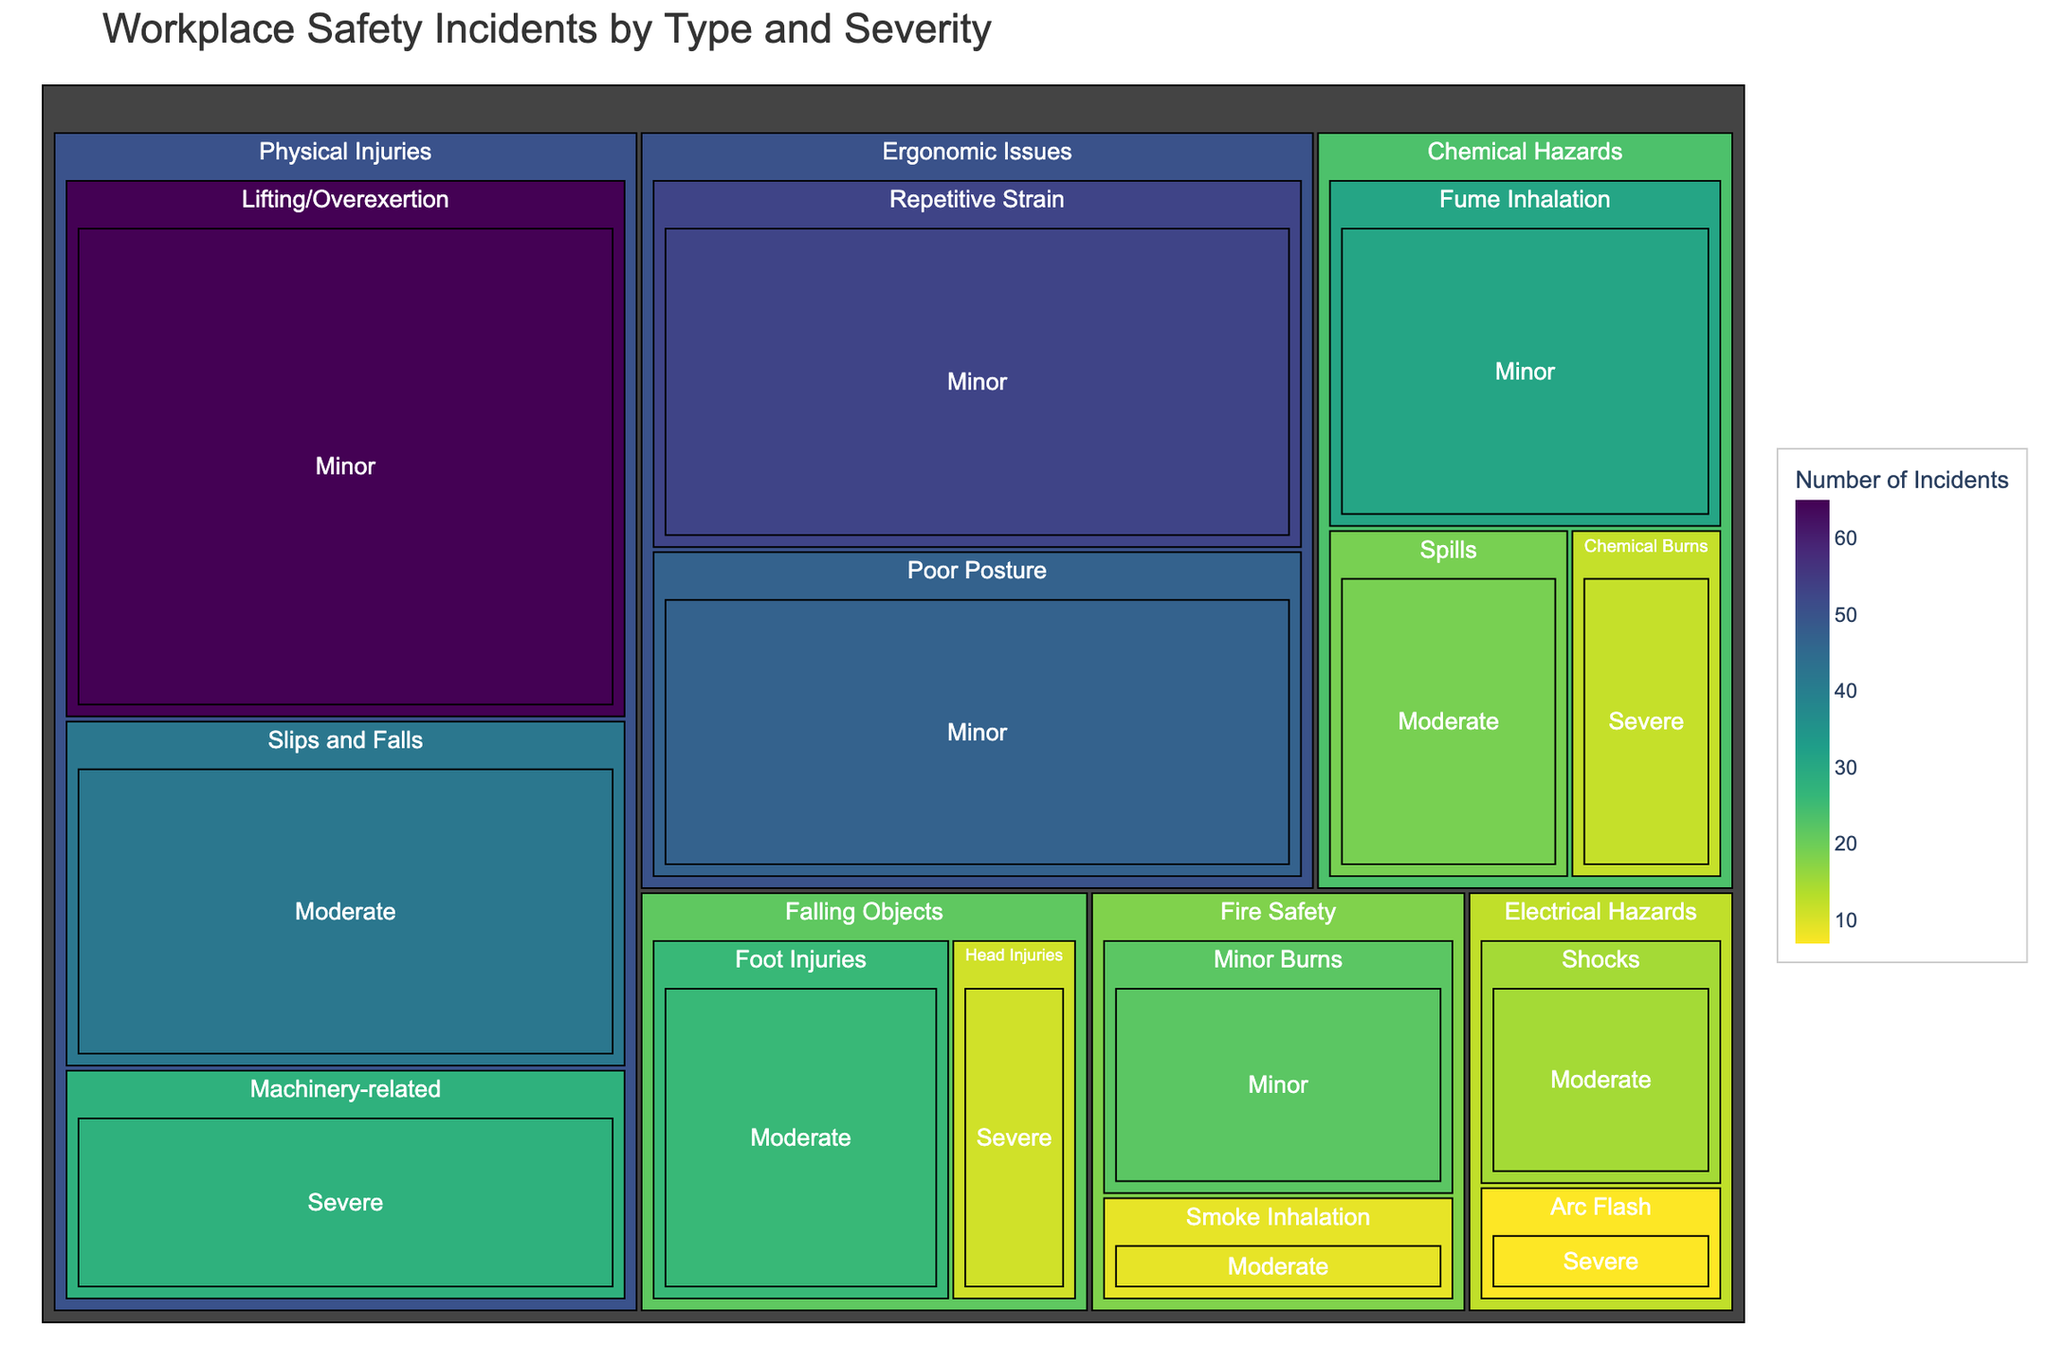What is the title of the treemap? The title of the treemap is displayed prominently at the top and provides an overview of the figure.
Answer: Workplace Safety Incidents by Type and Severity Which category has the highest number of total incidents? To determine the highest category, sum the incidents for each main category (Physical Injuries, Chemical Hazards, Ergonomic Issues, Electrical Hazards, Fire Safety, Falling Objects) and compare the totals. For example, Physical Injuries: 42 + 28 + 65 = 135. Proceed similarly for other categories.
Answer: Physical Injuries How many severe incidents are due to machinery-related accidents? Locate the Machinery-related section under Physical Injuries and find the number specified for severe incidents.
Answer: 28 What is the total number of moderate incidents in the treemap? Sum the incidents for all moderate severity subtotals. For example, Slips and Falls (42), Spills (19), Shocks (15), Smoke Inhalation (9), Head Injuries (11), Foot Injuries (26). Total = 42 + 19 + 15 + 9 + 11 + 26 = 122.
Answer: 122 Which type of incident under Chemical Hazards has the least number of incidents? Examine the subdivisions under Chemical Hazards for the lowest value. Compare Spills (19), Fume Inhalation (31), Chemical Burns (12).
Answer: Chemical Burns How does the number of minor ergonomic issues compare with minor fire safety incidents? Find and compare the values for Repetitive Strain (53) and Poor Posture (47) under Ergonomic Issues against Minor Burns (22) under Fire Safety. Total Ergonomic Issues (53 + 47 = 100) vs. Fire Safety (22).
Answer: Ergonomic Issues have more What is the proportion of severe incidents within the Physical Injuries category? Calculate the proportion of severe incidents by dividing Machinery-related (28) by the total incidents in Physical Injuries (135). Proportion = 28 / 135 ≈ 0.207.
Answer: 0.207 Does the treemap indicate that slips and falls are more frequent than lifting/overexertion incidents? Compare the incidences for both types under Physical Injuries (Slips and Falls: 42, Lifting/Overexertion: 65).
Answer: No, lifting/overexertion incidents are more frequent Which category has the smallest visual block on the treemap and how many incidents does it represent? Visually identify the smallest block and refer to its associated incident number.
Answer: Electrical Hazards with 7 incidents for Arc Flash What is the average number of incidents for falling objects type? Sum the incidents for Head Injuries (11) and Foot Injuries (26) and divide by the total types (2). Average = (11 + 26) / 2 = 18.5.
Answer: 18.5 